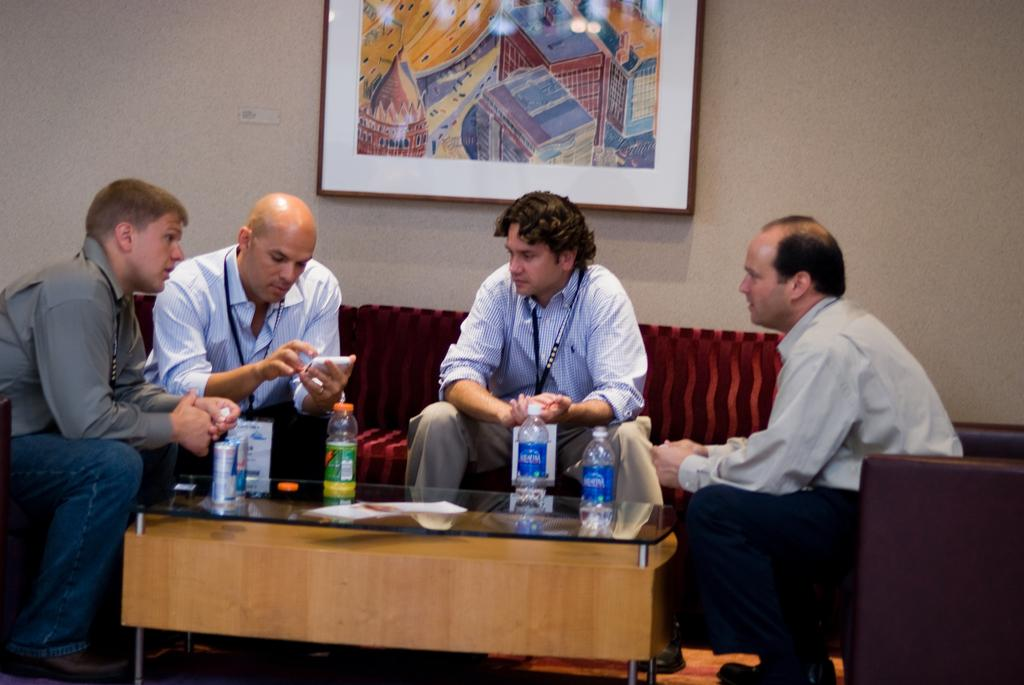How many people are sitting on the sofa in the image? There are four persons sitting on the sofa in the image. What are the persons doing while sitting on the sofa? The persons are sitting around a table in the image. What objects can be seen on the table? There are bottles and tins on the table in the image. What can be seen on the wall in the background? There is a photo frame visible on the wall in the background. What type of icicle can be seen hanging from the ceiling in the image? There is no icicle present in the image; it takes place indoors and does not involve any frozen precipitation. 